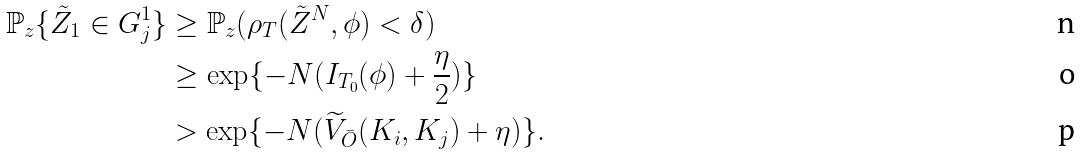<formula> <loc_0><loc_0><loc_500><loc_500>\mathbb { P } _ { z } \{ \tilde { Z } _ { 1 } \in G ^ { 1 } _ { j } \} & \geq \mathbb { P } _ { z } ( \rho _ { T } ( \tilde { Z } ^ { N } , \phi ) < \delta ) \\ & \geq \exp \{ - N ( I _ { T _ { 0 } } ( \phi ) + \frac { \eta } { 2 } ) \} \\ & > \exp \{ - N ( \widetilde { V } _ { \bar { O } } ( K _ { i } , K _ { j } ) + \eta ) \} .</formula> 